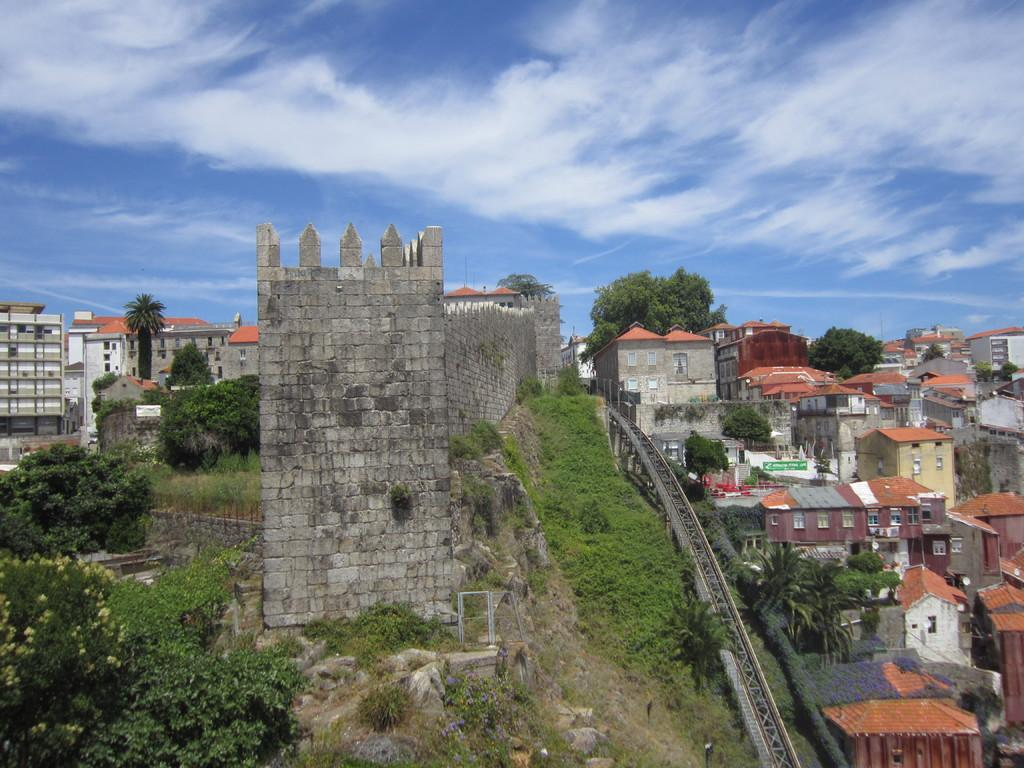What type of structures can be seen in the image? There are many buildings present in the image. What other elements can be found in the image besides buildings? There are trees in the image. What is the condition of the sky in the image? The sky is clear in the image. How many crows are pulling the buildings in the image? There are no crows present in the image, and they are not pulling any buildings. 